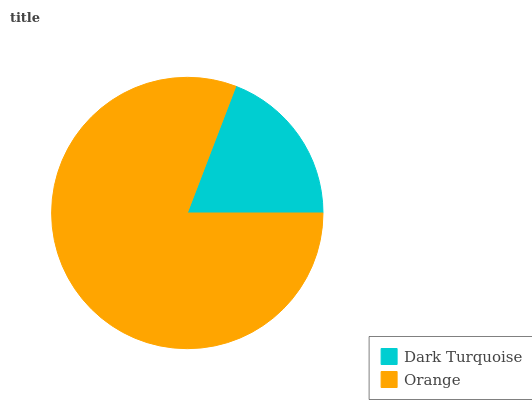Is Dark Turquoise the minimum?
Answer yes or no. Yes. Is Orange the maximum?
Answer yes or no. Yes. Is Orange the minimum?
Answer yes or no. No. Is Orange greater than Dark Turquoise?
Answer yes or no. Yes. Is Dark Turquoise less than Orange?
Answer yes or no. Yes. Is Dark Turquoise greater than Orange?
Answer yes or no. No. Is Orange less than Dark Turquoise?
Answer yes or no. No. Is Orange the high median?
Answer yes or no. Yes. Is Dark Turquoise the low median?
Answer yes or no. Yes. Is Dark Turquoise the high median?
Answer yes or no. No. Is Orange the low median?
Answer yes or no. No. 